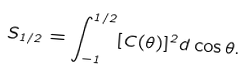Convert formula to latex. <formula><loc_0><loc_0><loc_500><loc_500>S _ { 1 / 2 } = \int _ { - 1 } ^ { 1 / 2 } [ C ( \theta ) ] ^ { 2 } d \cos \theta .</formula> 